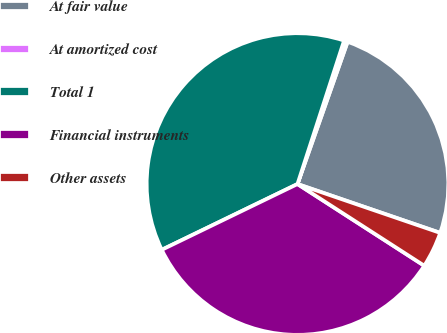<chart> <loc_0><loc_0><loc_500><loc_500><pie_chart><fcel>At fair value<fcel>At amortized cost<fcel>Total 1<fcel>Financial instruments<fcel>Other assets<nl><fcel>24.86%<fcel>0.39%<fcel>37.18%<fcel>33.71%<fcel>3.86%<nl></chart> 